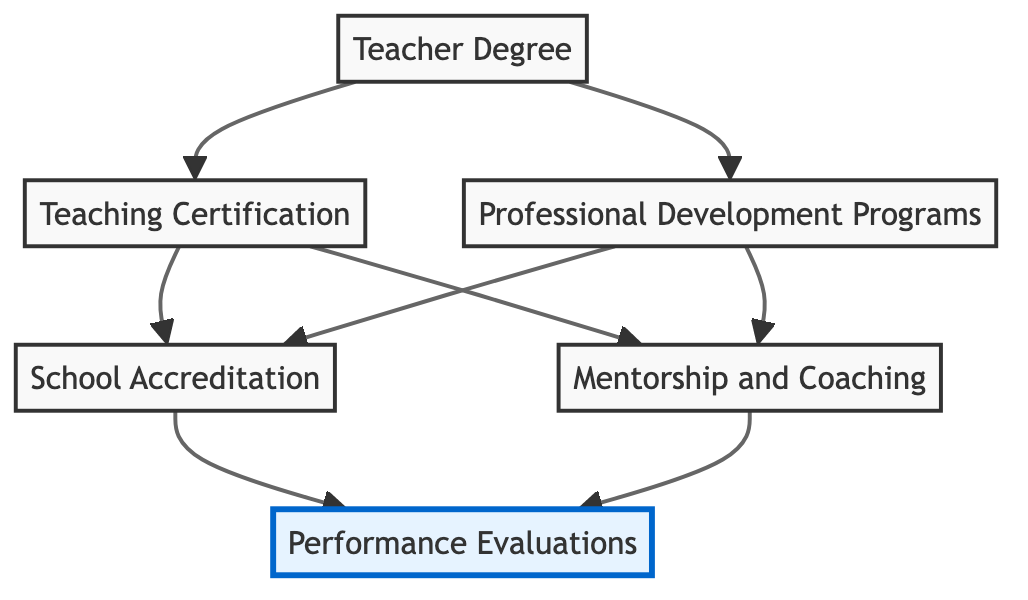What is the first element in the flow chart? The first element in the flow chart is "Teacher Degree," which is the starting point before the flow progresses to other components.
Answer: Teacher Degree How many main elements are in the diagram? The diagram consists of six main elements: Teacher Degree, Teaching Certification, Professional Development Programs, School Accreditation, Mentorship and Coaching, and Performance Evaluations.
Answer: Six Which two elements lead to "School Accreditation"? The elements that lead to "School Accreditation" are "Teaching Certification" and "Professional Development Programs," indicating that both are necessary components for achieving accreditation.
Answer: Teaching Certification and Professional Development Programs What is the final outcome of the flow chart? The final outcome of the flow chart is "Performance Evaluations," which represents the culmination of the various qualification assessments flowing from the preceding elements.
Answer: Performance Evaluations How is "Mentorship and Coaching" connected to "Performance Evaluations"? "Mentorship and Coaching" is connected to "Performance Evaluations" as an intermediary step, meaning that mentoring and coaching lead to improved performance evaluations in educators.
Answer: Through Mentorship and Coaching What role does "Teacher Degree" play in the flow chart? "Teacher Degree" serves as the foundational element upon which further qualifications and certifications are built; it is the first step in the flow leading to evaluations of educator qualification.
Answer: Foundational element What do "Teaching Certification" and "Professional Development Programs" have in common based on the diagram? Both "Teaching Certification" and "Professional Development Programs" are essential qualifications that contribute to "School Accreditation," showing they are critical components in preparing teachers for evaluation.
Answer: They both contribute to School Accreditation Which element receives connections from the greatest number of other elements? "Performance Evaluations" receives connections from "School Accreditation" and "Mentorship and Coaching," making it the element with the most incoming connections from other parts of the flow chart.
Answer: Performance Evaluations How does the diagram reflect a bottom-up approach to assessing educator qualifications? The diagram illustrates a bottom-up approach by starting from foundational qualifications like a teacher’s degree and building up through certifications and development programs to culminate in performance evaluations, thus showing the progression of assessment from base to top.
Answer: By starting with foundational qualifications 